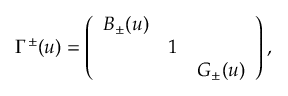Convert formula to latex. <formula><loc_0><loc_0><loc_500><loc_500>\Gamma ^ { \pm } ( u ) = \left ( \begin{array} { c c c } { { B _ { \pm } ( u ) } } & { 1 } & { { G _ { \pm } ( u ) } } \end{array} \right ) ,</formula> 